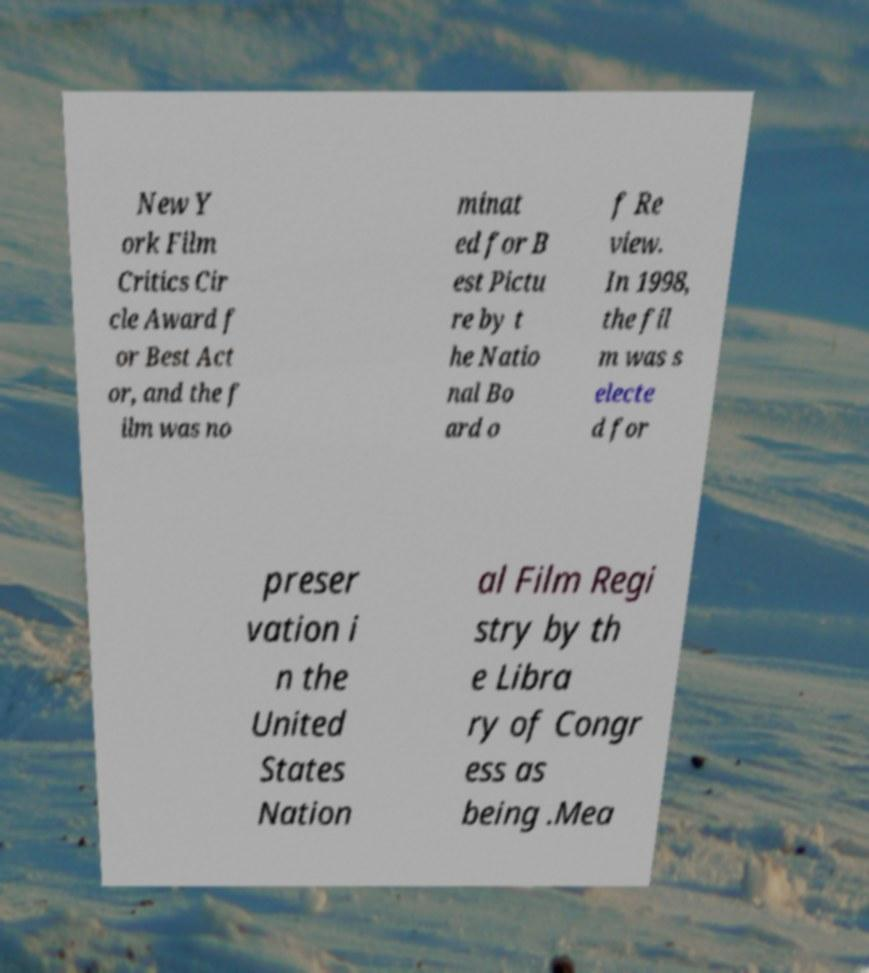Please read and relay the text visible in this image. What does it say? New Y ork Film Critics Cir cle Award f or Best Act or, and the f ilm was no minat ed for B est Pictu re by t he Natio nal Bo ard o f Re view. In 1998, the fil m was s electe d for preser vation i n the United States Nation al Film Regi stry by th e Libra ry of Congr ess as being .Mea 